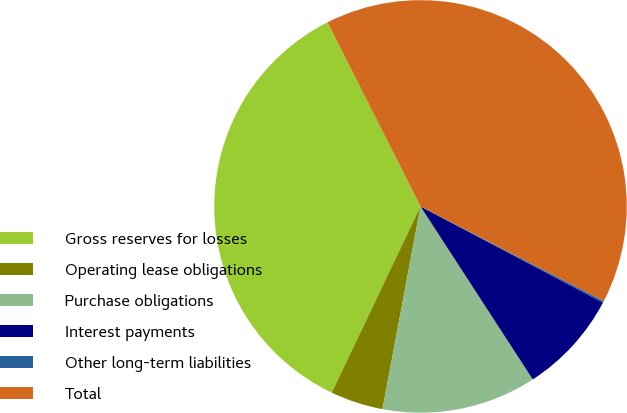<chart> <loc_0><loc_0><loc_500><loc_500><pie_chart><fcel>Gross reserves for losses<fcel>Operating lease obligations<fcel>Purchase obligations<fcel>Interest payments<fcel>Other long-term liabilities<fcel>Total<nl><fcel>35.47%<fcel>4.13%<fcel>12.11%<fcel>8.12%<fcel>0.14%<fcel>40.03%<nl></chart> 